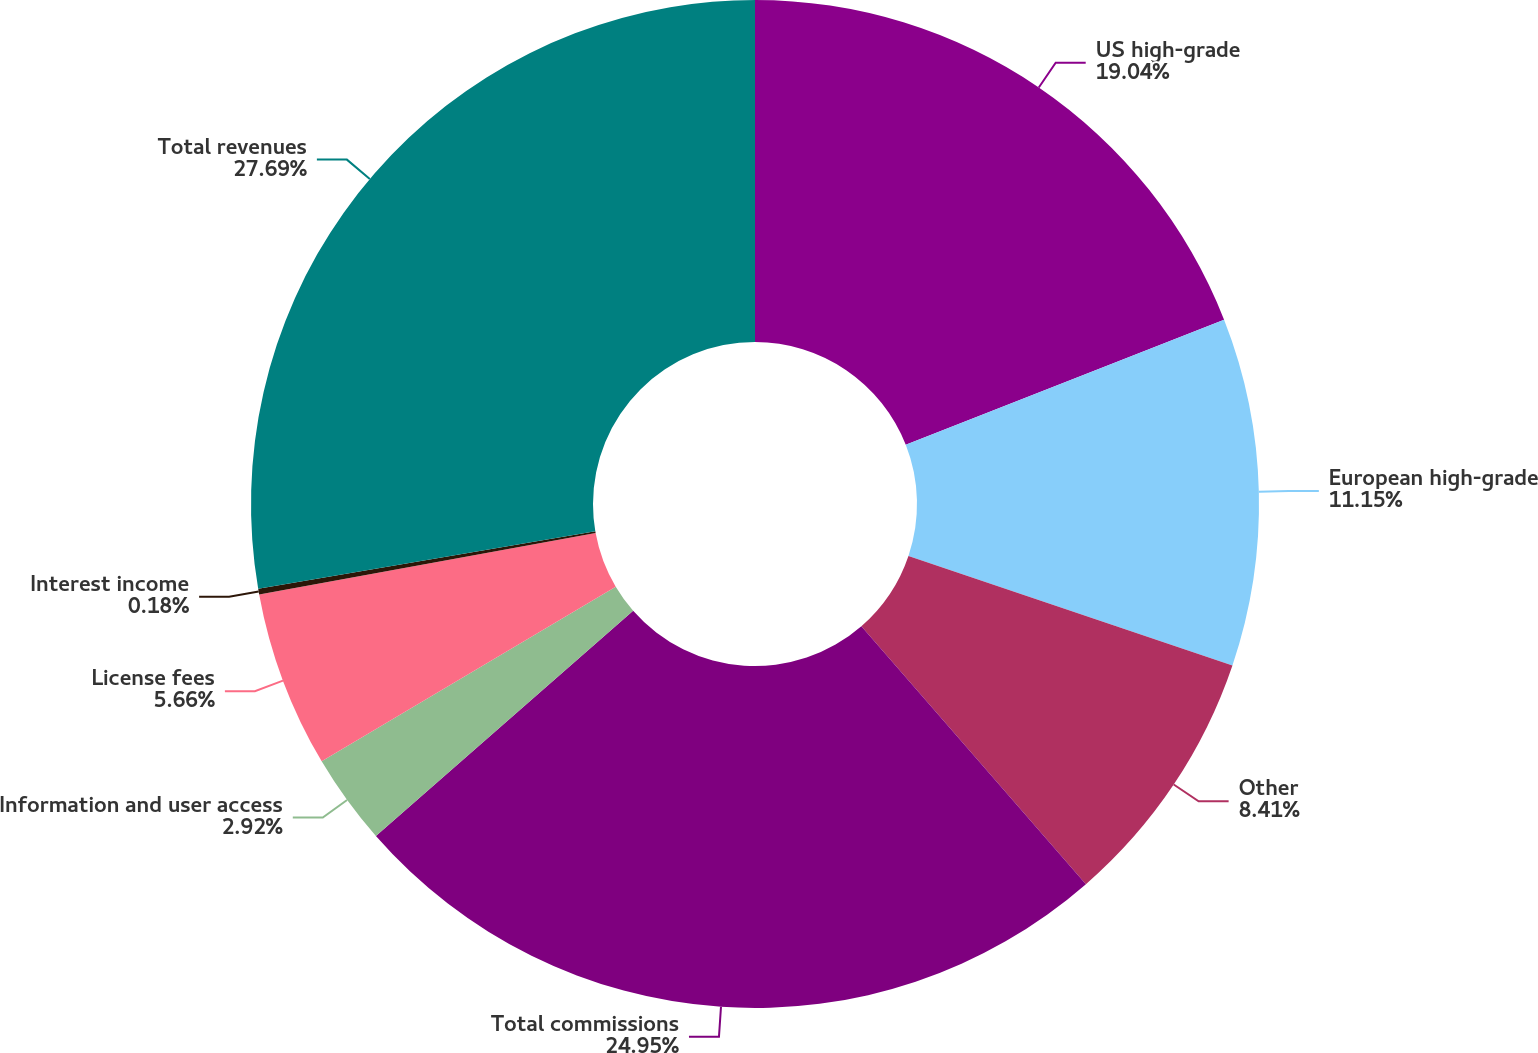Convert chart. <chart><loc_0><loc_0><loc_500><loc_500><pie_chart><fcel>US high-grade<fcel>European high-grade<fcel>Other<fcel>Total commissions<fcel>Information and user access<fcel>License fees<fcel>Interest income<fcel>Total revenues<nl><fcel>19.04%<fcel>11.15%<fcel>8.41%<fcel>24.95%<fcel>2.92%<fcel>5.66%<fcel>0.18%<fcel>27.69%<nl></chart> 